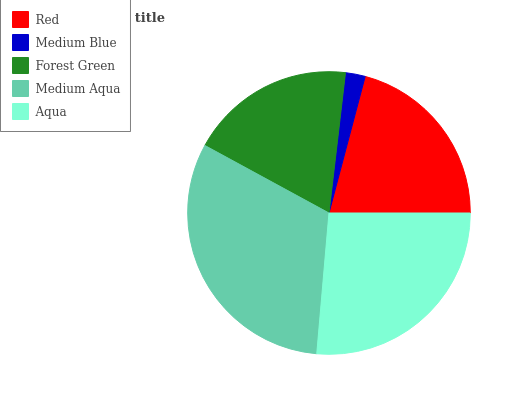Is Medium Blue the minimum?
Answer yes or no. Yes. Is Medium Aqua the maximum?
Answer yes or no. Yes. Is Forest Green the minimum?
Answer yes or no. No. Is Forest Green the maximum?
Answer yes or no. No. Is Forest Green greater than Medium Blue?
Answer yes or no. Yes. Is Medium Blue less than Forest Green?
Answer yes or no. Yes. Is Medium Blue greater than Forest Green?
Answer yes or no. No. Is Forest Green less than Medium Blue?
Answer yes or no. No. Is Red the high median?
Answer yes or no. Yes. Is Red the low median?
Answer yes or no. Yes. Is Forest Green the high median?
Answer yes or no. No. Is Medium Blue the low median?
Answer yes or no. No. 